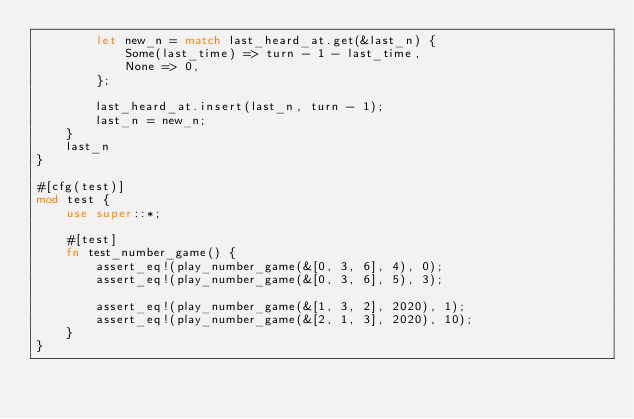Convert code to text. <code><loc_0><loc_0><loc_500><loc_500><_Rust_>        let new_n = match last_heard_at.get(&last_n) {
            Some(last_time) => turn - 1 - last_time,
            None => 0,
        };

        last_heard_at.insert(last_n, turn - 1);
        last_n = new_n;
    }
    last_n
}

#[cfg(test)]
mod test {
    use super::*;

    #[test]
    fn test_number_game() {
        assert_eq!(play_number_game(&[0, 3, 6], 4), 0);
        assert_eq!(play_number_game(&[0, 3, 6], 5), 3);

        assert_eq!(play_number_game(&[1, 3, 2], 2020), 1);
        assert_eq!(play_number_game(&[2, 1, 3], 2020), 10);
    }
}
</code> 